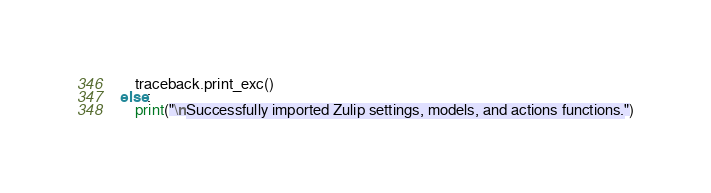Convert code to text. <code><loc_0><loc_0><loc_500><loc_500><_Python_>    traceback.print_exc()
else:
    print("\nSuccessfully imported Zulip settings, models, and actions functions.")
</code> 